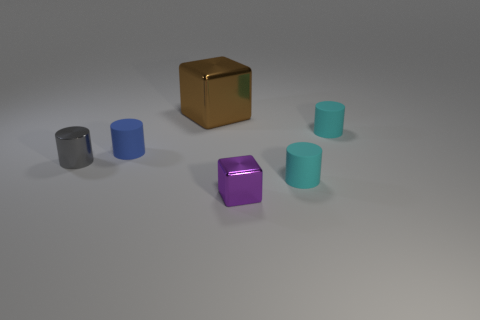Is the number of big brown metal objects behind the purple shiny block greater than the number of brown metal things to the left of the blue matte object? Upon observing the image, it appears that there is one large brown metal cube situated behind the purple shiny block. To the left of the blue matte object, no brown metal things are visible. Therefore, the number of big brown metal objects behind the purple block is indeed greater, as there is one such object, compared to none to the left of the blue matte object. 